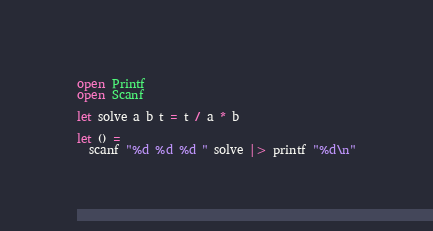Convert code to text. <code><loc_0><loc_0><loc_500><loc_500><_OCaml_>open Printf
open Scanf

let solve a b t = t / a * b

let () =
  scanf "%d %d %d " solve |> printf "%d\n"
</code> 